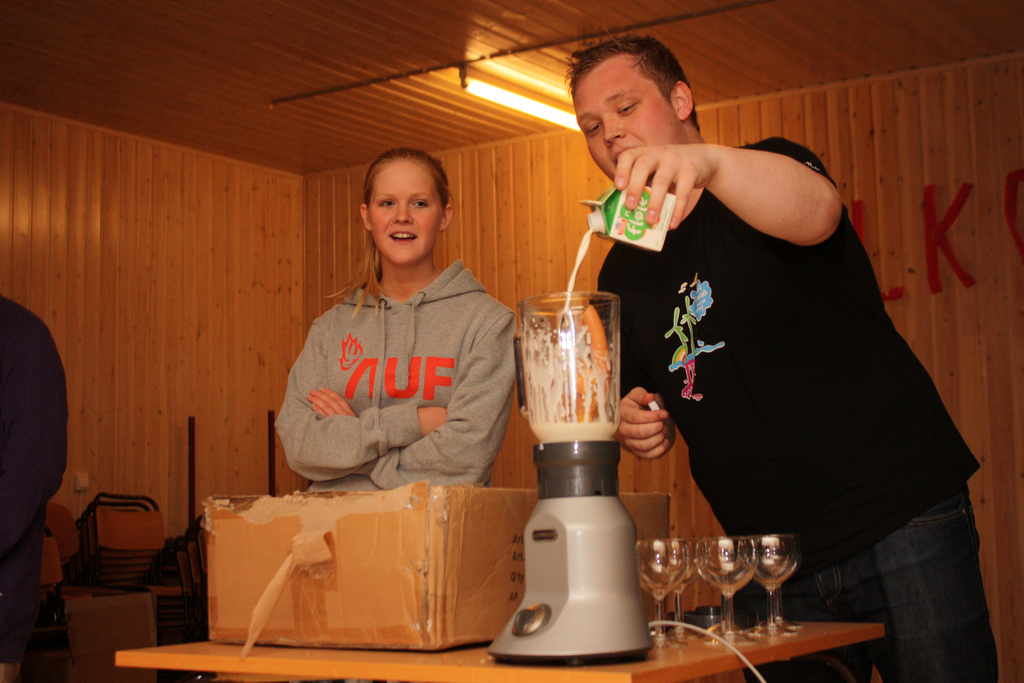What are these people preparing with the blender? It looks like they are making a fruit smoothie or a similar beverage, judging by the young man pouring juice into the blender which already contains what appears to be carrots. 